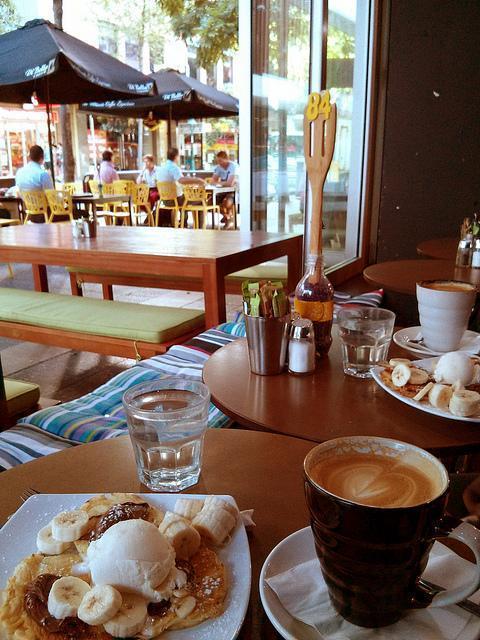What does the number 84 represent?
Choose the correct response and explain in the format: 'Answer: answer
Rationale: rationale.'
Options: Table number, store number, order number, price. Answer: order number.
Rationale: The number is there so the waiter can know which table to serve. 